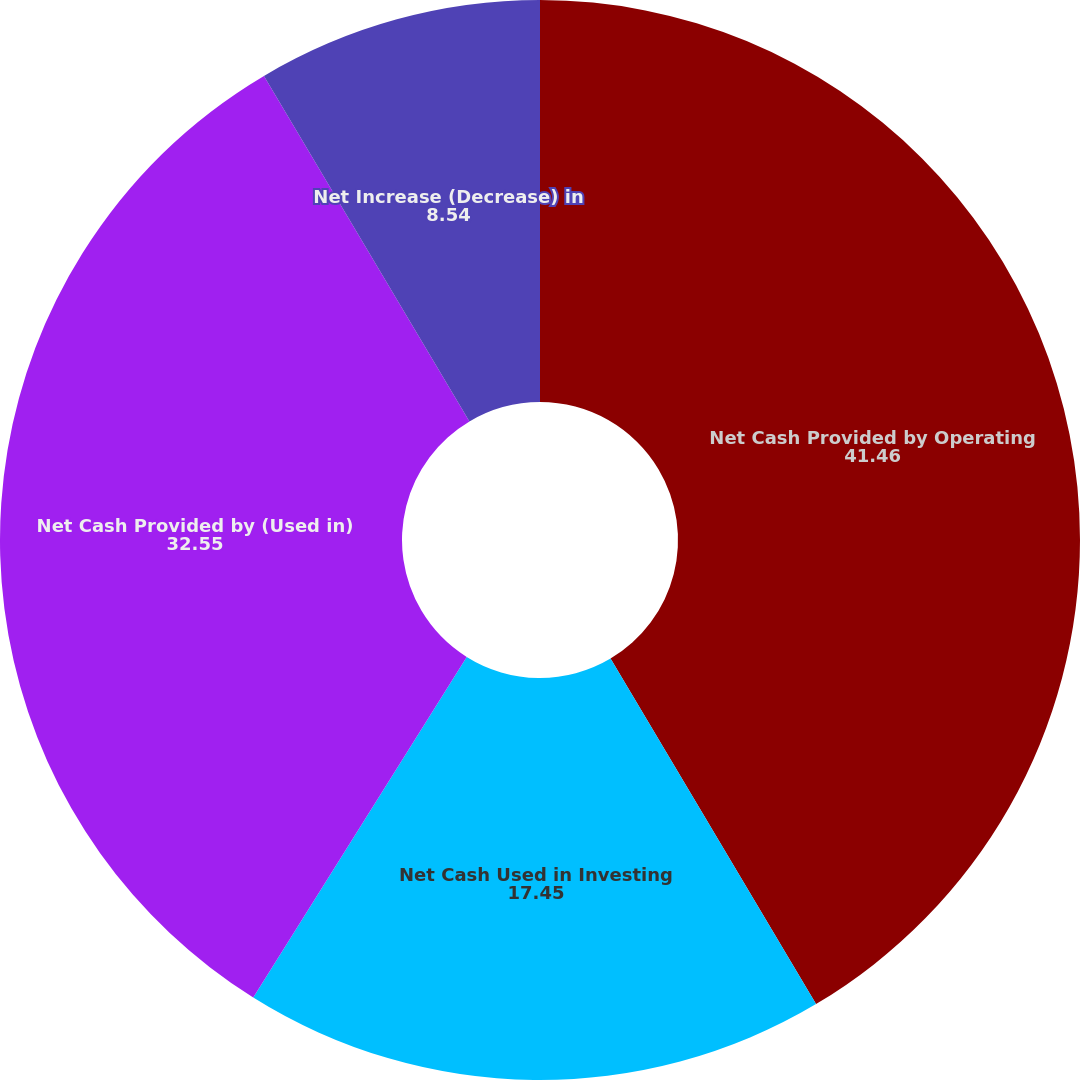<chart> <loc_0><loc_0><loc_500><loc_500><pie_chart><fcel>Net Cash Provided by Operating<fcel>Net Cash Used in Investing<fcel>Net Cash Provided by (Used in)<fcel>Net Increase (Decrease) in<nl><fcel>41.46%<fcel>17.45%<fcel>32.55%<fcel>8.54%<nl></chart> 